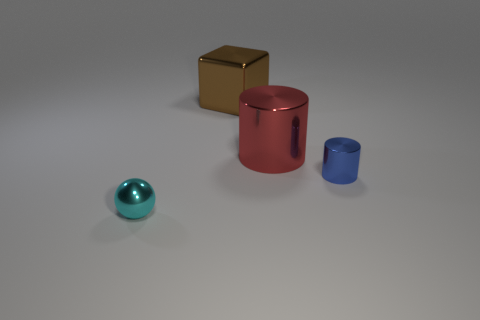There is another object that is the same shape as the big red metal thing; what is it made of? The smaller blue object shares the cylindrical shape with the larger red object. It appears to be made of a similar material, likely a matte-finished metal. 